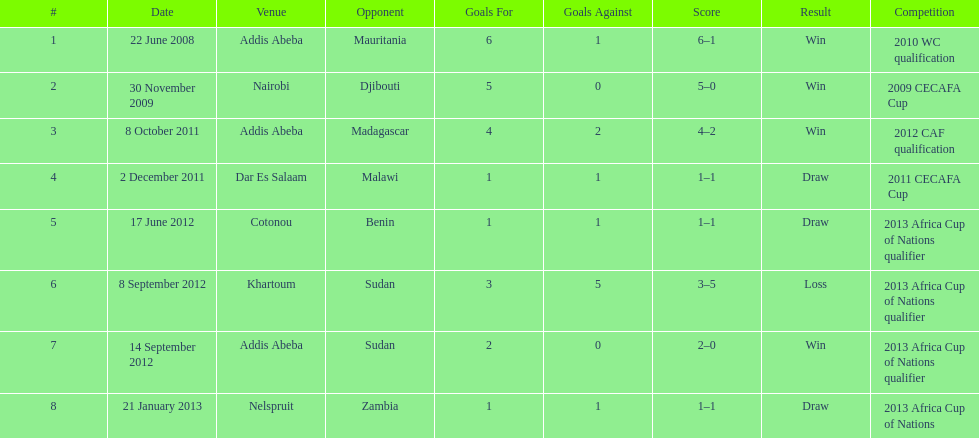True or false? in comparison, the ethiopian national team has more draws than wins. False. 